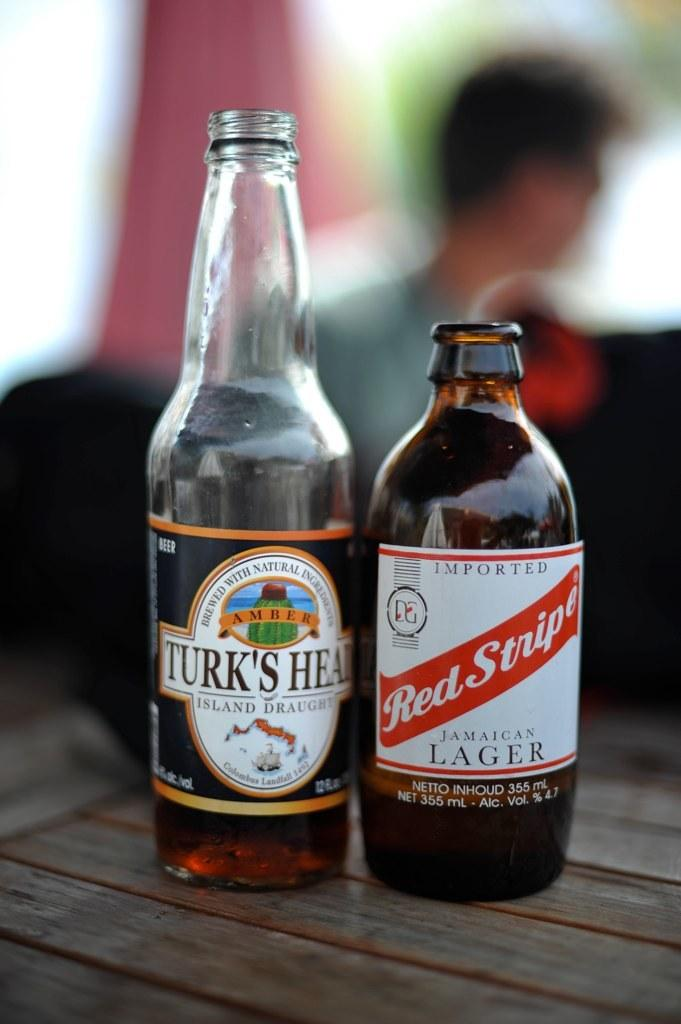<image>
Present a compact description of the photo's key features. A bottle of Turk's Head and Red Stripes lager beer on a table. 